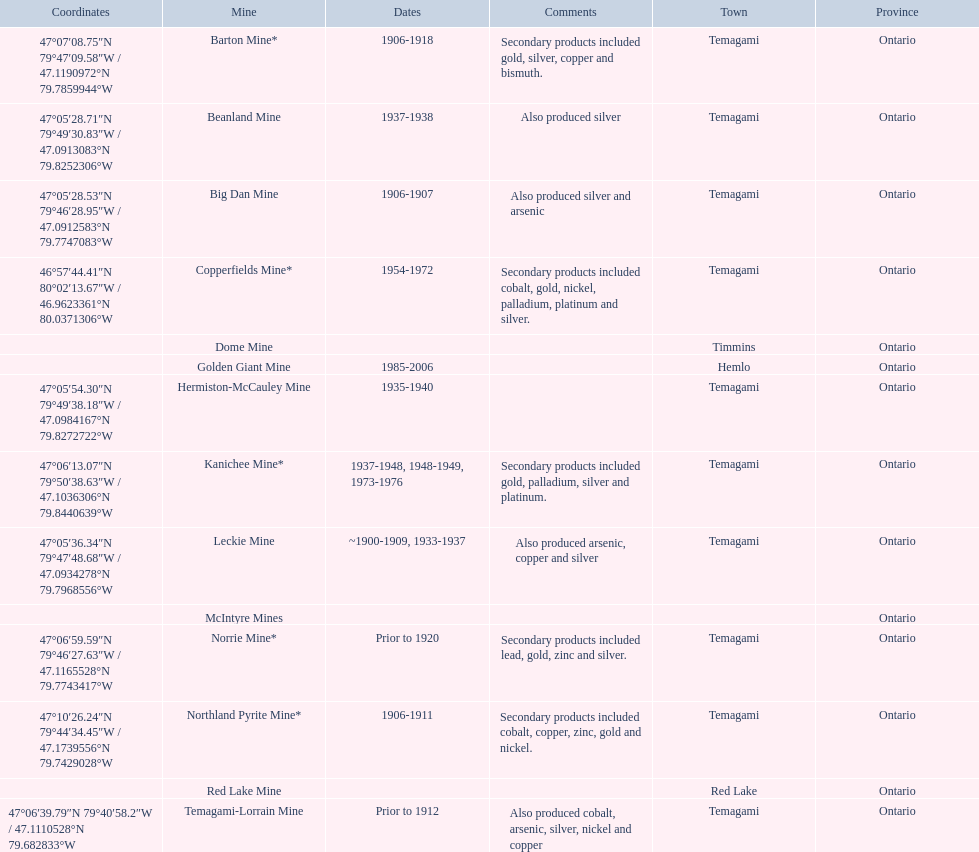What dates was the golden giant mine open? 1985-2006. What dates was the beanland mine open? 1937-1938. Of those mines, which was open longer? Golden Giant Mine. 